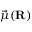<formula> <loc_0><loc_0><loc_500><loc_500>\vec { \mu } ( R )</formula> 